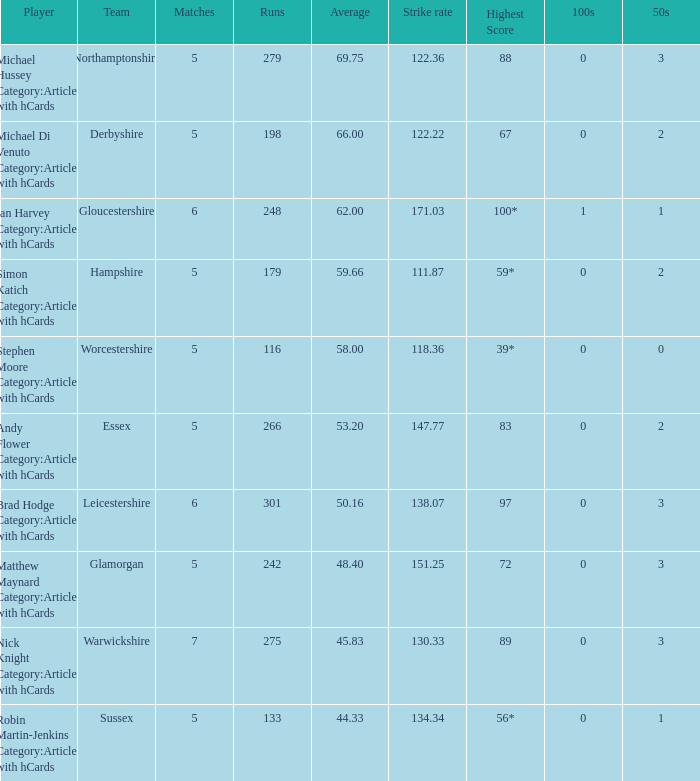If the highest score is 88, what are the 50s? 3.0. Could you parse the entire table? {'header': ['Player', 'Team', 'Matches', 'Runs', 'Average', 'Strike rate', 'Highest Score', '100s', '50s'], 'rows': [['Michael Hussey Category:Articles with hCards', 'Northamptonshire', '5', '279', '69.75', '122.36', '88', '0', '3'], ['Michael Di Venuto Category:Articles with hCards', 'Derbyshire', '5', '198', '66.00', '122.22', '67', '0', '2'], ['Ian Harvey Category:Articles with hCards', 'Gloucestershire', '6', '248', '62.00', '171.03', '100*', '1', '1'], ['Simon Katich Category:Articles with hCards', 'Hampshire', '5', '179', '59.66', '111.87', '59*', '0', '2'], ['Stephen Moore Category:Articles with hCards', 'Worcestershire', '5', '116', '58.00', '118.36', '39*', '0', '0'], ['Andy Flower Category:Articles with hCards', 'Essex', '5', '266', '53.20', '147.77', '83', '0', '2'], ['Brad Hodge Category:Articles with hCards', 'Leicestershire', '6', '301', '50.16', '138.07', '97', '0', '3'], ['Matthew Maynard Category:Articles with hCards', 'Glamorgan', '5', '242', '48.40', '151.25', '72', '0', '3'], ['Nick Knight Category:Articles with hCards', 'Warwickshire', '7', '275', '45.83', '130.33', '89', '0', '3'], ['Robin Martin-Jenkins Category:Articles with hCards', 'Sussex', '5', '133', '44.33', '134.34', '56*', '0', '1']]} 